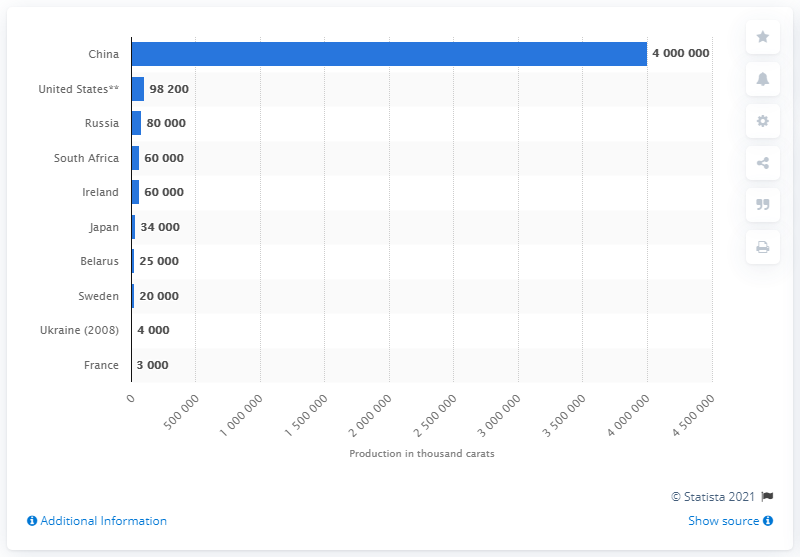Outline some significant characteristics in this image. In 2011, China produced an estimated four billion carats of synthetic diamonds, making it the country that produced the largest amount of synthetic diamonds that year. 